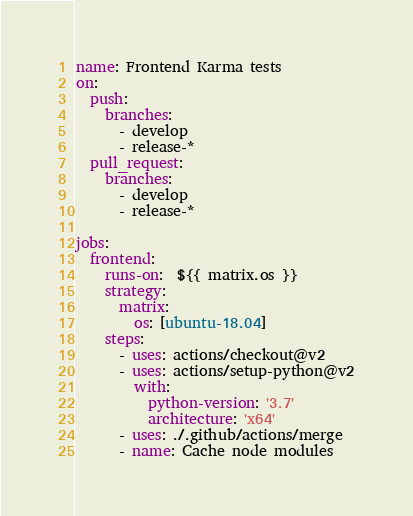<code> <loc_0><loc_0><loc_500><loc_500><_YAML_>name: Frontend Karma tests
on:
  push:
    branches:
      - develop
      - release-*
  pull_request:
    branches:
      - develop
      - release-*

jobs:
  frontend:
    runs-on:  ${{ matrix.os }}
    strategy:
      matrix:
        os: [ubuntu-18.04]
    steps:
      - uses: actions/checkout@v2
      - uses: actions/setup-python@v2
        with:
          python-version: '3.7'
          architecture: 'x64'
      - uses: ./.github/actions/merge
      - name: Cache node modules</code> 